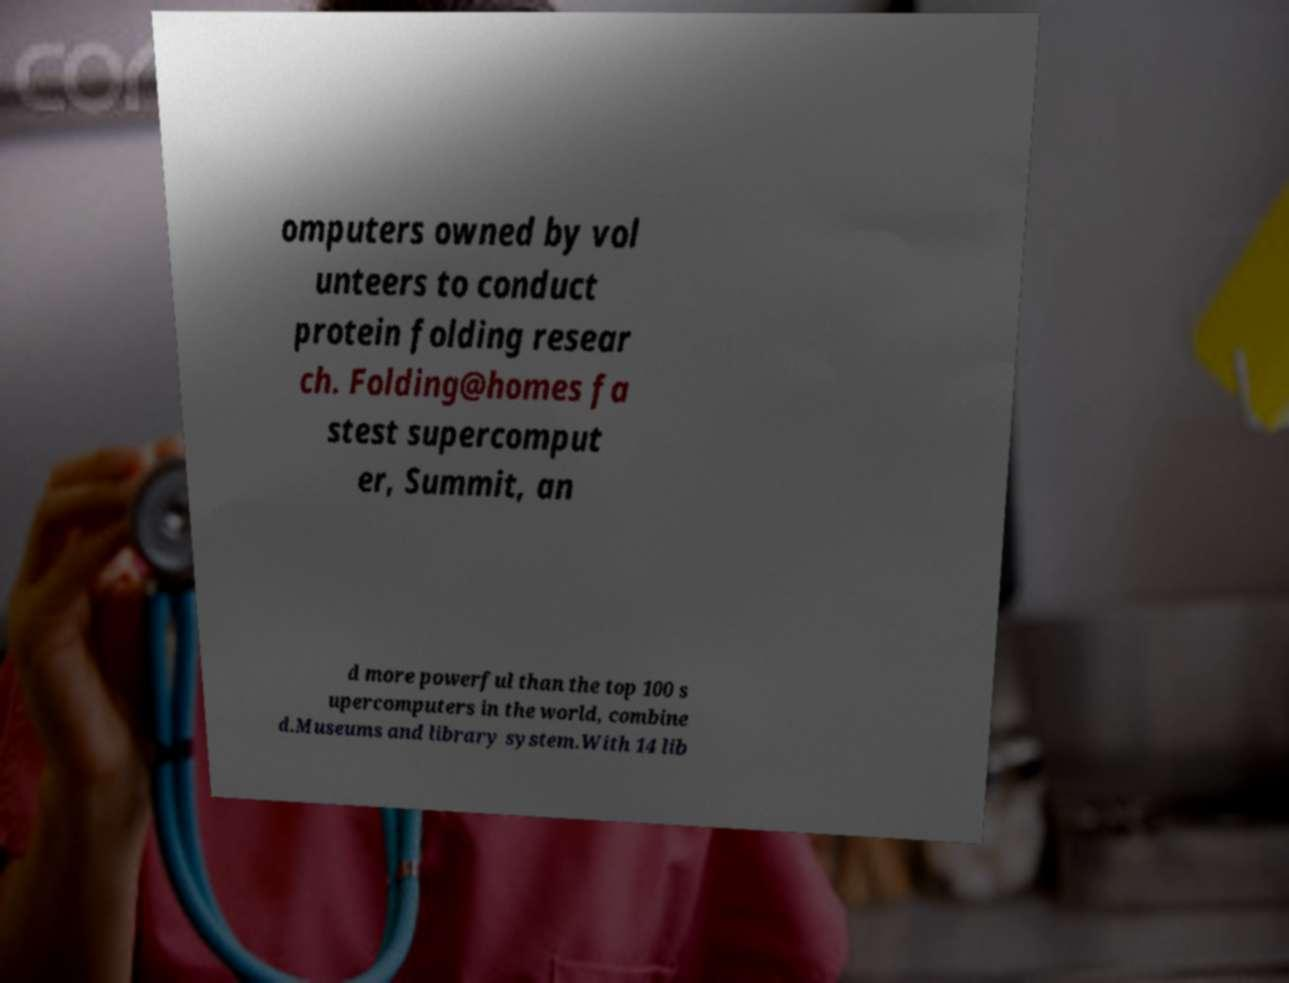Can you read and provide the text displayed in the image?This photo seems to have some interesting text. Can you extract and type it out for me? omputers owned by vol unteers to conduct protein folding resear ch. Folding@homes fa stest supercomput er, Summit, an d more powerful than the top 100 s upercomputers in the world, combine d.Museums and library system.With 14 lib 